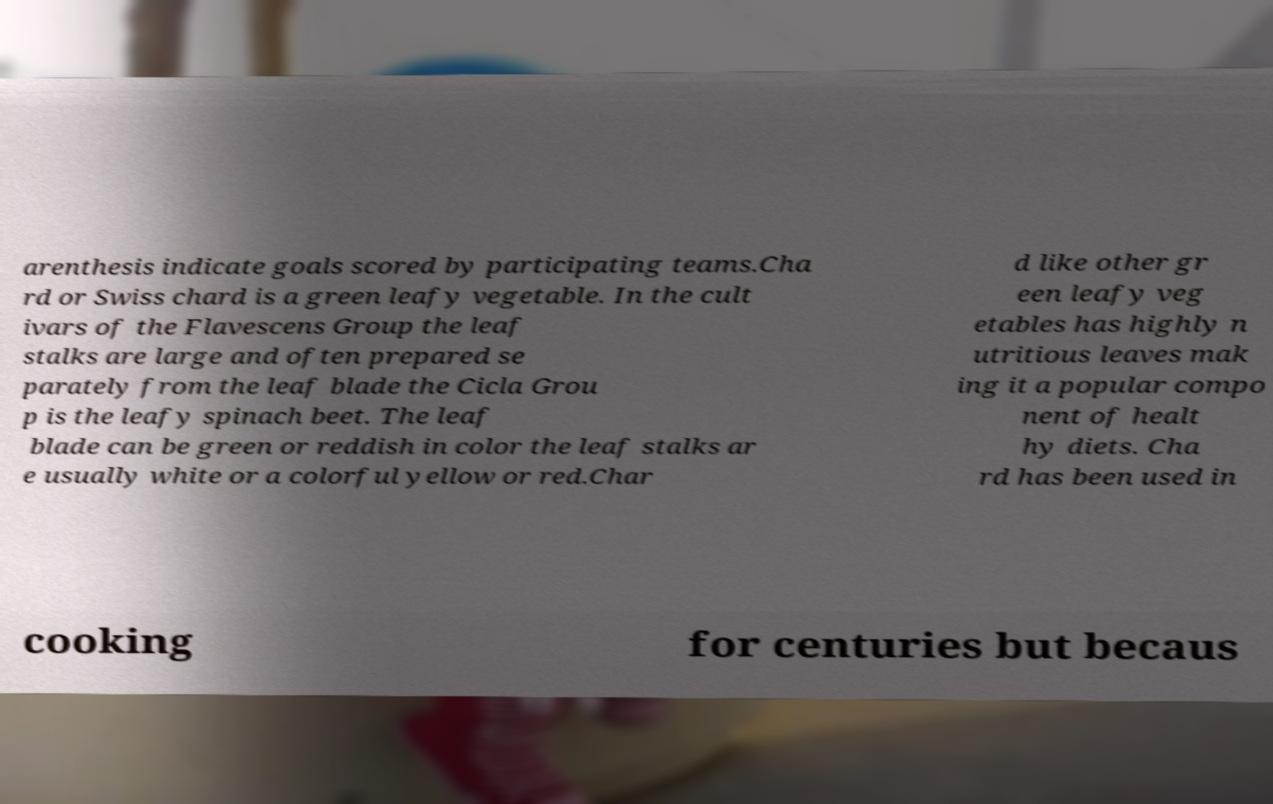There's text embedded in this image that I need extracted. Can you transcribe it verbatim? arenthesis indicate goals scored by participating teams.Cha rd or Swiss chard is a green leafy vegetable. In the cult ivars of the Flavescens Group the leaf stalks are large and often prepared se parately from the leaf blade the Cicla Grou p is the leafy spinach beet. The leaf blade can be green or reddish in color the leaf stalks ar e usually white or a colorful yellow or red.Char d like other gr een leafy veg etables has highly n utritious leaves mak ing it a popular compo nent of healt hy diets. Cha rd has been used in cooking for centuries but becaus 